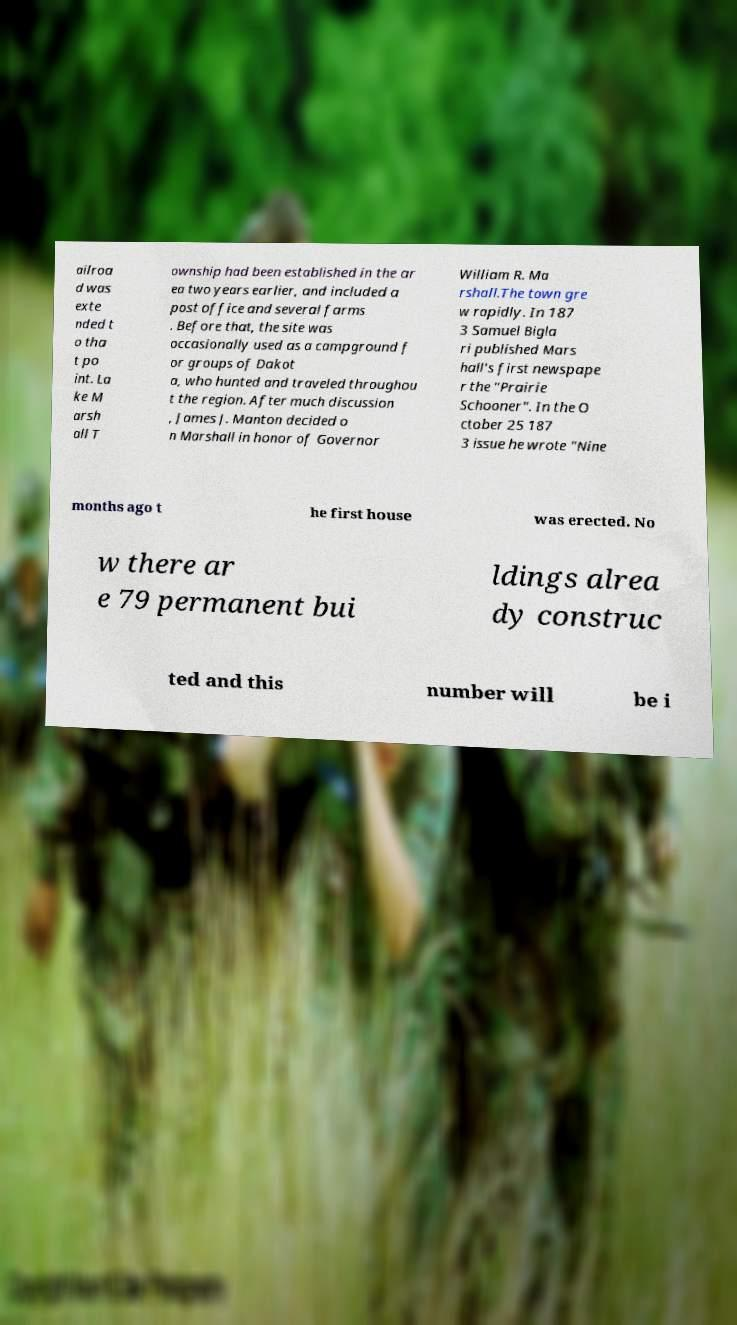Could you assist in decoding the text presented in this image and type it out clearly? ailroa d was exte nded t o tha t po int. La ke M arsh all T ownship had been established in the ar ea two years earlier, and included a post office and several farms . Before that, the site was occasionally used as a campground f or groups of Dakot a, who hunted and traveled throughou t the region. After much discussion , James J. Manton decided o n Marshall in honor of Governor William R. Ma rshall.The town gre w rapidly. In 187 3 Samuel Bigla ri published Mars hall's first newspape r the "Prairie Schooner". In the O ctober 25 187 3 issue he wrote "Nine months ago t he first house was erected. No w there ar e 79 permanent bui ldings alrea dy construc ted and this number will be i 